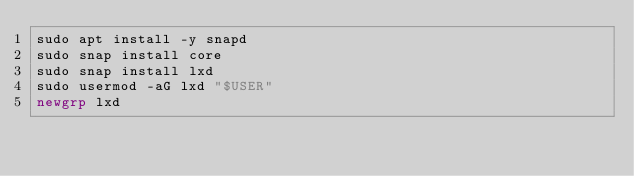Convert code to text. <code><loc_0><loc_0><loc_500><loc_500><_Bash_>sudo apt install -y snapd
sudo snap install core
sudo snap install lxd
sudo usermod -aG lxd "$USER"
newgrp lxd
</code> 